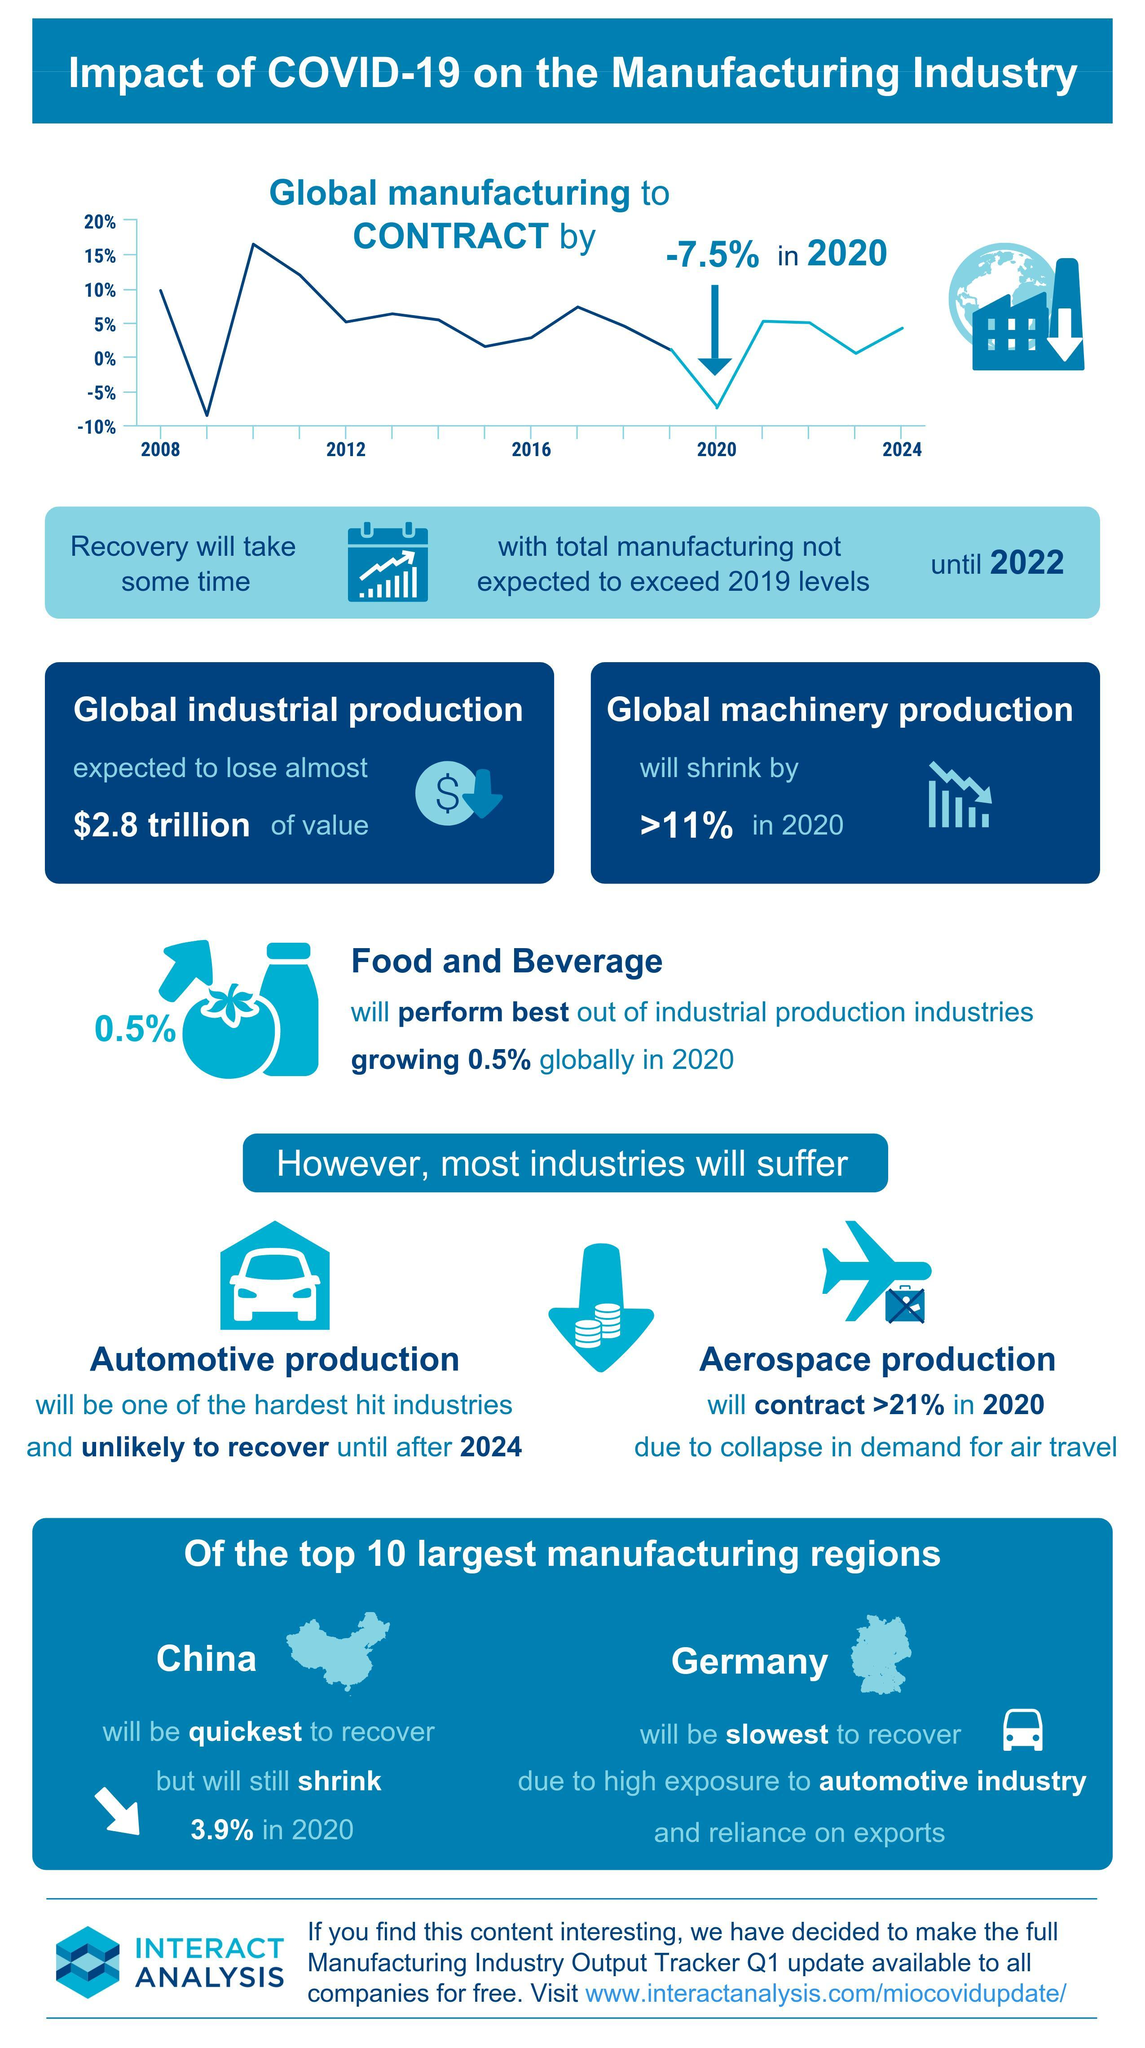How much is the minimum decline expected this year in Aerospace production?
Answer the question with a short phrase. >21% The proper recovery of manufacturing industry cannot be expected till which year? 2022 Which industrial sector is expected to do well worldwide in 2020? Food and Beverage How much is the expected reduction in the global manufacturing industry in the year 2020? 7.5% What is the expected loss of value in industrial production worldwide? $2.8 trillion Which industrial sector is hit hard due to the decline in demand for air travel? Aerospace production Which country is expected to recover fastest among the manufacturing regions? China How much is the expected reduction in 2020 worldwide machinery production? 11% Which sector will find it tough to recover for at least the next 4 years? Automotive production Which European country relies much on automotive industry and exports? Germany 